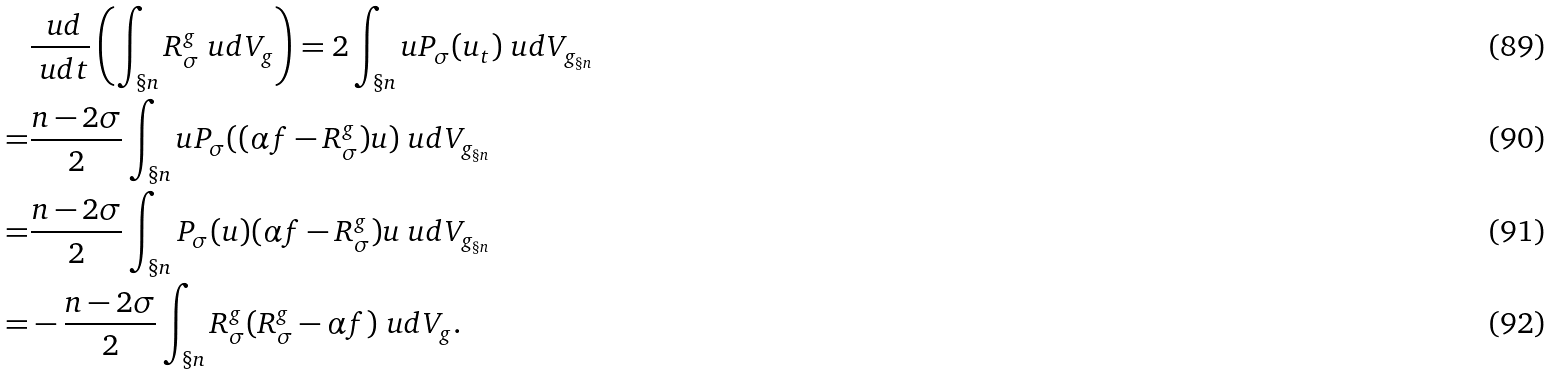<formula> <loc_0><loc_0><loc_500><loc_500>& \frac { \ u d } { \ u d t } \left ( \int _ { \S n } R _ { \sigma } ^ { g } \ u d V _ { g } \right ) = 2 \int _ { \S n } u P _ { \sigma } ( u _ { t } ) \ u d V _ { g _ { \S n } } \\ = & \frac { n - 2 \sigma } { 2 } \int _ { \S n } u P _ { \sigma } ( ( \alpha f - R _ { \sigma } ^ { g } ) u ) \ u d V _ { g _ { \S n } } \\ = & \frac { n - 2 \sigma } { 2 } \int _ { \S n } P _ { \sigma } ( u ) ( \alpha f - R _ { \sigma } ^ { g } ) u \ u d V _ { g _ { \S n } } \\ = & - \frac { n - 2 \sigma } { 2 } \int _ { \S n } R _ { \sigma } ^ { g } ( R _ { \sigma } ^ { g } - \alpha f ) \ u d V _ { g } .</formula> 